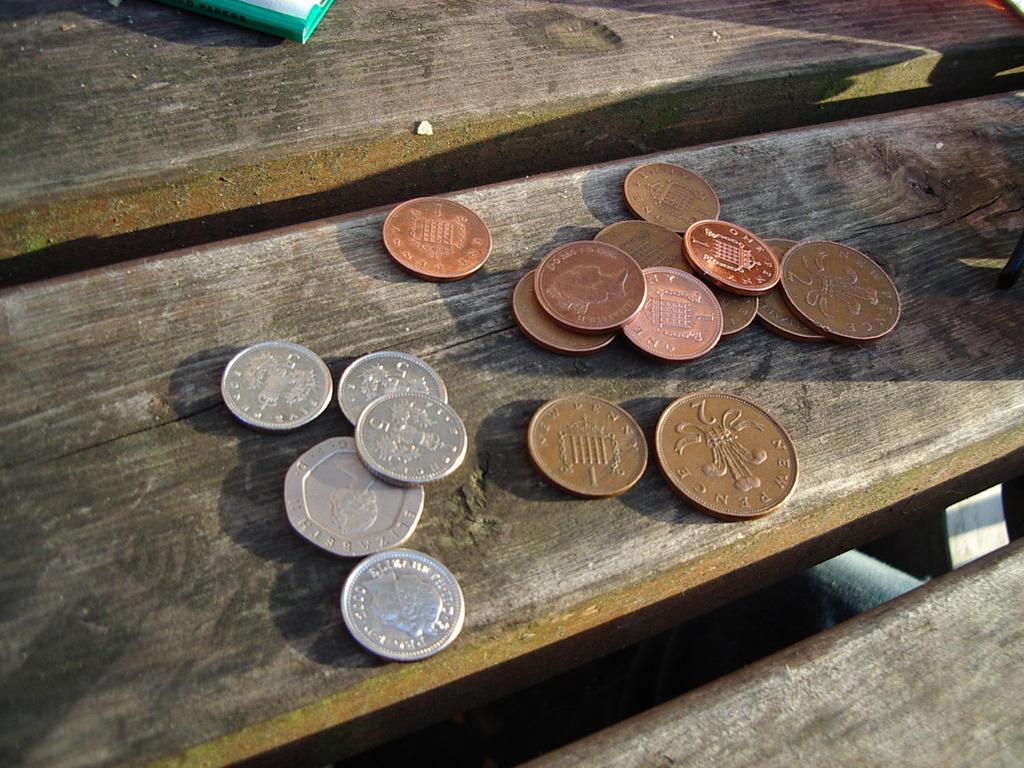<image>
Offer a succinct explanation of the picture presented. A couple of one cent pennies sit on a table. 